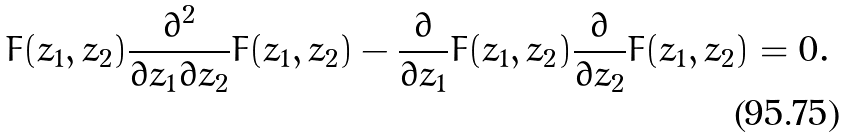<formula> <loc_0><loc_0><loc_500><loc_500>F ( z _ { 1 } , z _ { 2 } ) \frac { \partial ^ { 2 } } { \partial z _ { 1 } \partial z _ { 2 } } F ( z _ { 1 } , z _ { 2 } ) - \frac { \partial } { \partial z _ { 1 } } F ( z _ { 1 } , z _ { 2 } ) \frac { \partial } { \partial z _ { 2 } } F ( z _ { 1 } , z _ { 2 } ) = 0 .</formula> 